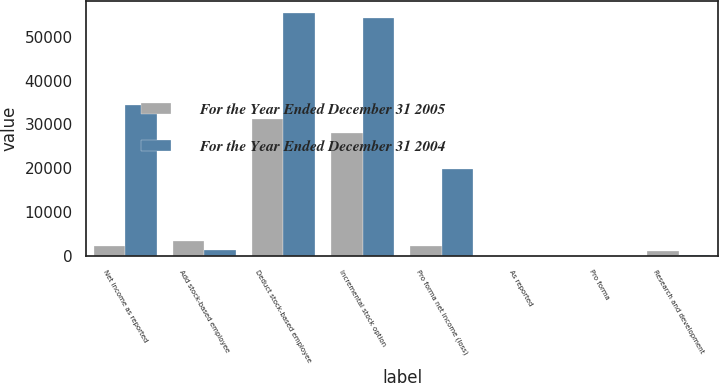<chart> <loc_0><loc_0><loc_500><loc_500><stacked_bar_chart><ecel><fcel>Net income as reported<fcel>Add stock-based employee<fcel>Deduct stock-based employee<fcel>Incremental stock option<fcel>Pro forma net income (loss)<fcel>As reported<fcel>Pro forma<fcel>Research and development<nl><fcel>For the Year Ended December 31 2005<fcel>2209.5<fcel>3219<fcel>31288<fcel>28069<fcel>2209.5<fcel>2.41<fcel>2.2<fcel>1034<nl><fcel>For the Year Ended December 31 2004<fcel>34364<fcel>1200<fcel>55461<fcel>54261<fcel>19897<fcel>0.28<fcel>0.16<fcel>118<nl></chart> 